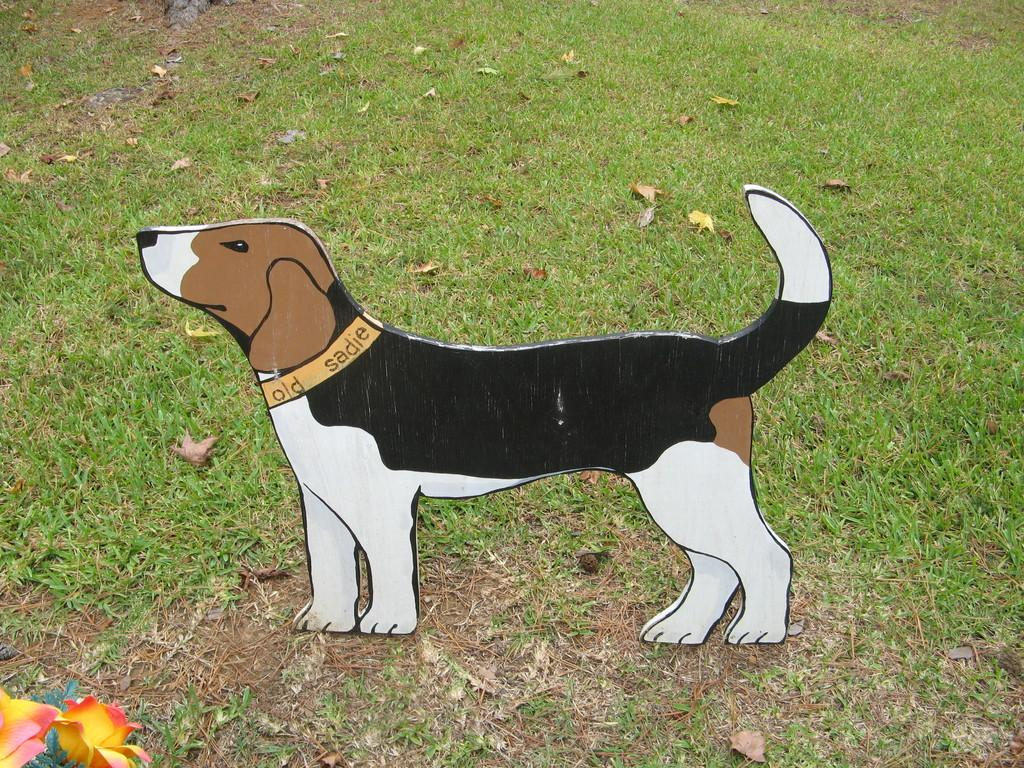What is depicted on the board in the image? There is a board of a dog in the image. Where is the board placed? The board is placed on a surface. What type of terrain is visible in the image? There is soil and grass visible in the image. What kind of plants can be seen in the image? There are flowers at the left side bottom corner of the image. What type of fog can be seen in the image? There is no fog present in the image. What attraction is featured in the image? The image does not depict any specific attraction; it primarily features a board of a dog and the surrounding terrain. 